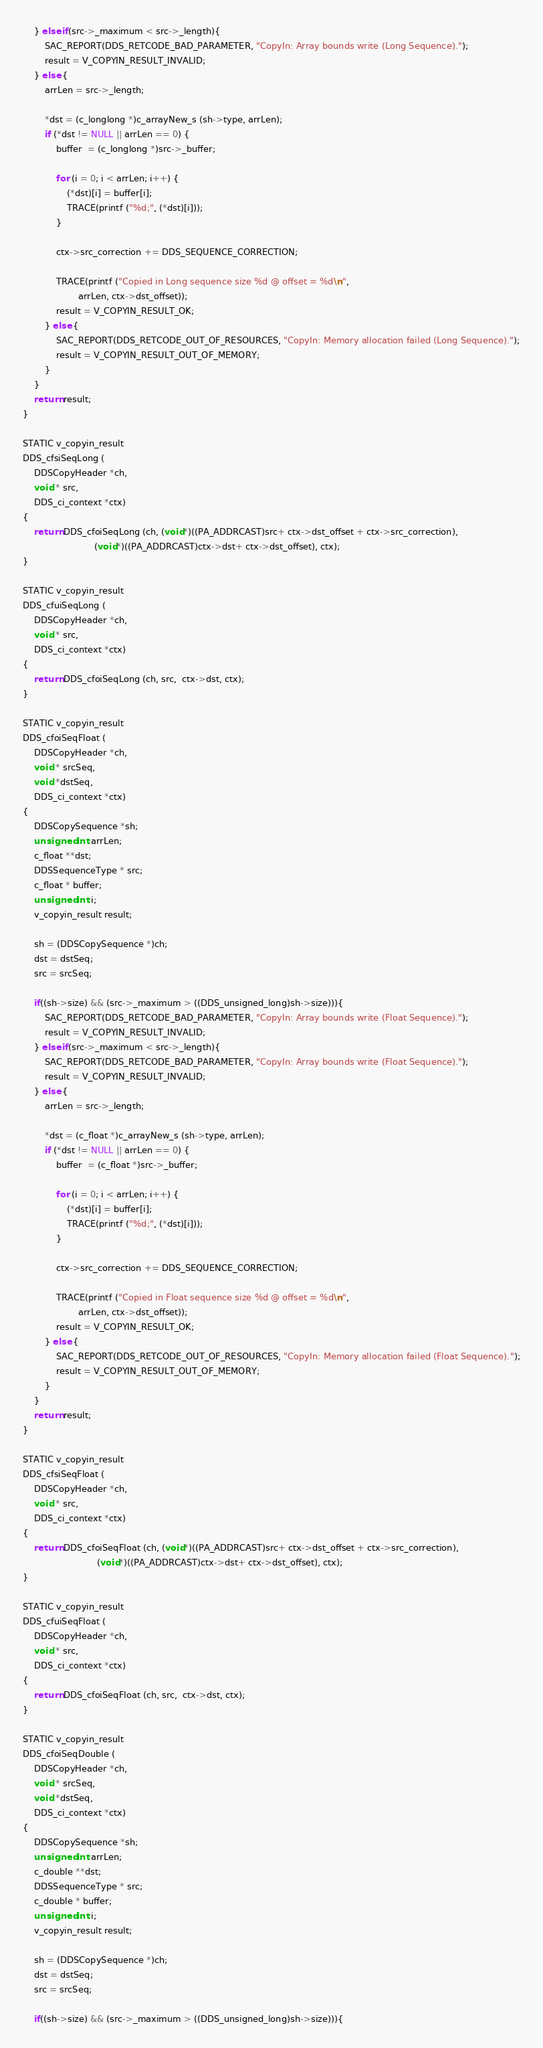Convert code to text. <code><loc_0><loc_0><loc_500><loc_500><_C_>    } else if(src->_maximum < src->_length){
        SAC_REPORT(DDS_RETCODE_BAD_PARAMETER, "CopyIn: Array bounds write (Long Sequence).");
        result = V_COPYIN_RESULT_INVALID;
    } else {
        arrLen = src->_length;

        *dst = (c_longlong *)c_arrayNew_s (sh->type, arrLen);
        if (*dst != NULL || arrLen == 0) {
            buffer  = (c_longlong *)src->_buffer;

            for (i = 0; i < arrLen; i++) {
                (*dst)[i] = buffer[i];
                TRACE(printf ("%d;", (*dst)[i]));
            }

            ctx->src_correction += DDS_SEQUENCE_CORRECTION;

            TRACE(printf ("Copied in Long sequence size %d @ offset = %d\n",
                    arrLen, ctx->dst_offset));
            result = V_COPYIN_RESULT_OK;
        } else {
            SAC_REPORT(DDS_RETCODE_OUT_OF_RESOURCES, "CopyIn: Memory allocation failed (Long Sequence).");
            result = V_COPYIN_RESULT_OUT_OF_MEMORY;
        }
    }
    return result;
}

STATIC v_copyin_result
DDS_cfsiSeqLong (
    DDSCopyHeader *ch,
    void * src,
    DDS_ci_context *ctx)
{
    return DDS_cfoiSeqLong (ch, (void*)((PA_ADDRCAST)src+ ctx->dst_offset + ctx->src_correction),
                          (void*)((PA_ADDRCAST)ctx->dst+ ctx->dst_offset), ctx);
}

STATIC v_copyin_result
DDS_cfuiSeqLong (
    DDSCopyHeader *ch,
    void * src,
    DDS_ci_context *ctx)
{
    return DDS_cfoiSeqLong (ch, src,  ctx->dst, ctx);
}

STATIC v_copyin_result
DDS_cfoiSeqFloat (
    DDSCopyHeader *ch,
    void * srcSeq,
    void *dstSeq,
    DDS_ci_context *ctx)
{
    DDSCopySequence *sh;
    unsigned int arrLen;
    c_float **dst;
    DDSSequenceType * src;
    c_float * buffer;
    unsigned int i;
    v_copyin_result result;

    sh = (DDSCopySequence *)ch;
    dst = dstSeq;
    src = srcSeq;

    if((sh->size) && (src->_maximum > ((DDS_unsigned_long)sh->size))){
        SAC_REPORT(DDS_RETCODE_BAD_PARAMETER, "CopyIn: Array bounds write (Float Sequence).");
        result = V_COPYIN_RESULT_INVALID;
    } else if(src->_maximum < src->_length){
        SAC_REPORT(DDS_RETCODE_BAD_PARAMETER, "CopyIn: Array bounds write (Float Sequence).");
        result = V_COPYIN_RESULT_INVALID;
    } else {
        arrLen = src->_length;

        *dst = (c_float *)c_arrayNew_s (sh->type, arrLen);
        if (*dst != NULL || arrLen == 0) {
            buffer  = (c_float *)src->_buffer;

            for (i = 0; i < arrLen; i++) {
                (*dst)[i] = buffer[i];
                TRACE(printf ("%d;", (*dst)[i]));
            }

            ctx->src_correction += DDS_SEQUENCE_CORRECTION;

            TRACE(printf ("Copied in Float sequence size %d @ offset = %d\n",
                    arrLen, ctx->dst_offset));
            result = V_COPYIN_RESULT_OK;
        } else {
            SAC_REPORT(DDS_RETCODE_OUT_OF_RESOURCES, "CopyIn: Memory allocation failed (Float Sequence).");
            result = V_COPYIN_RESULT_OUT_OF_MEMORY;
        }
    }
    return result;
}

STATIC v_copyin_result
DDS_cfsiSeqFloat (
    DDSCopyHeader *ch,
    void * src,
    DDS_ci_context *ctx)
{
    return DDS_cfoiSeqFloat (ch, (void*)((PA_ADDRCAST)src+ ctx->dst_offset + ctx->src_correction),
                           (void*)((PA_ADDRCAST)ctx->dst+ ctx->dst_offset), ctx);
}

STATIC v_copyin_result
DDS_cfuiSeqFloat (
    DDSCopyHeader *ch,
    void * src,
    DDS_ci_context *ctx)
{
    return DDS_cfoiSeqFloat (ch, src,  ctx->dst, ctx);
}

STATIC v_copyin_result
DDS_cfoiSeqDouble (
    DDSCopyHeader *ch,
    void * srcSeq,
    void *dstSeq,
    DDS_ci_context *ctx)
{
    DDSCopySequence *sh;
    unsigned int arrLen;
    c_double **dst;
    DDSSequenceType * src;
    c_double * buffer;
    unsigned int i;
    v_copyin_result result;

    sh = (DDSCopySequence *)ch;
    dst = dstSeq;
    src = srcSeq;

    if((sh->size) && (src->_maximum > ((DDS_unsigned_long)sh->size))){</code> 